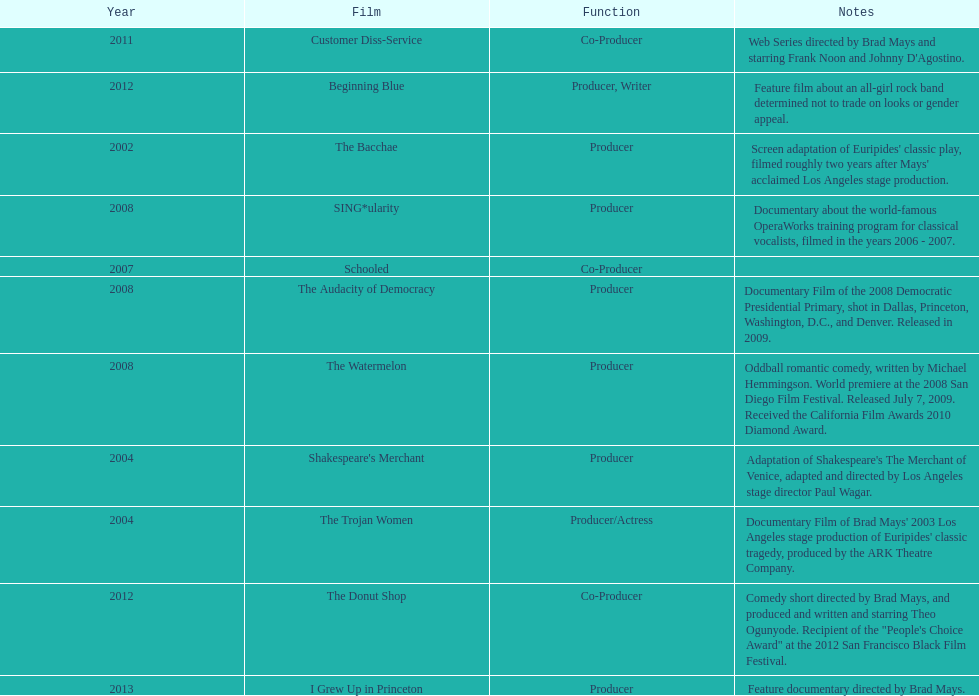In which year did ms. starfelt produce the most films? 2008. Could you parse the entire table as a dict? {'header': ['Year', 'Film', 'Function', 'Notes'], 'rows': [['2011', 'Customer Diss-Service', 'Co-Producer', "Web Series directed by Brad Mays and starring Frank Noon and Johnny D'Agostino."], ['2012', 'Beginning Blue', 'Producer, Writer', 'Feature film about an all-girl rock band determined not to trade on looks or gender appeal.'], ['2002', 'The Bacchae', 'Producer', "Screen adaptation of Euripides' classic play, filmed roughly two years after Mays' acclaimed Los Angeles stage production."], ['2008', 'SING*ularity', 'Producer', 'Documentary about the world-famous OperaWorks training program for classical vocalists, filmed in the years 2006 - 2007.'], ['2007', 'Schooled', 'Co-Producer', ''], ['2008', 'The Audacity of Democracy', 'Producer', 'Documentary Film of the 2008 Democratic Presidential Primary, shot in Dallas, Princeton, Washington, D.C., and Denver. Released in 2009.'], ['2008', 'The Watermelon', 'Producer', 'Oddball romantic comedy, written by Michael Hemmingson. World premiere at the 2008 San Diego Film Festival. Released July 7, 2009. Received the California Film Awards 2010 Diamond Award.'], ['2004', "Shakespeare's Merchant", 'Producer', "Adaptation of Shakespeare's The Merchant of Venice, adapted and directed by Los Angeles stage director Paul Wagar."], ['2004', 'The Trojan Women', 'Producer/Actress', "Documentary Film of Brad Mays' 2003 Los Angeles stage production of Euripides' classic tragedy, produced by the ARK Theatre Company."], ['2012', 'The Donut Shop', 'Co-Producer', 'Comedy short directed by Brad Mays, and produced and written and starring Theo Ogunyode. Recipient of the "People\'s Choice Award" at the 2012 San Francisco Black Film Festival.'], ['2013', 'I Grew Up in Princeton', 'Producer', 'Feature documentary directed by Brad Mays.']]} 